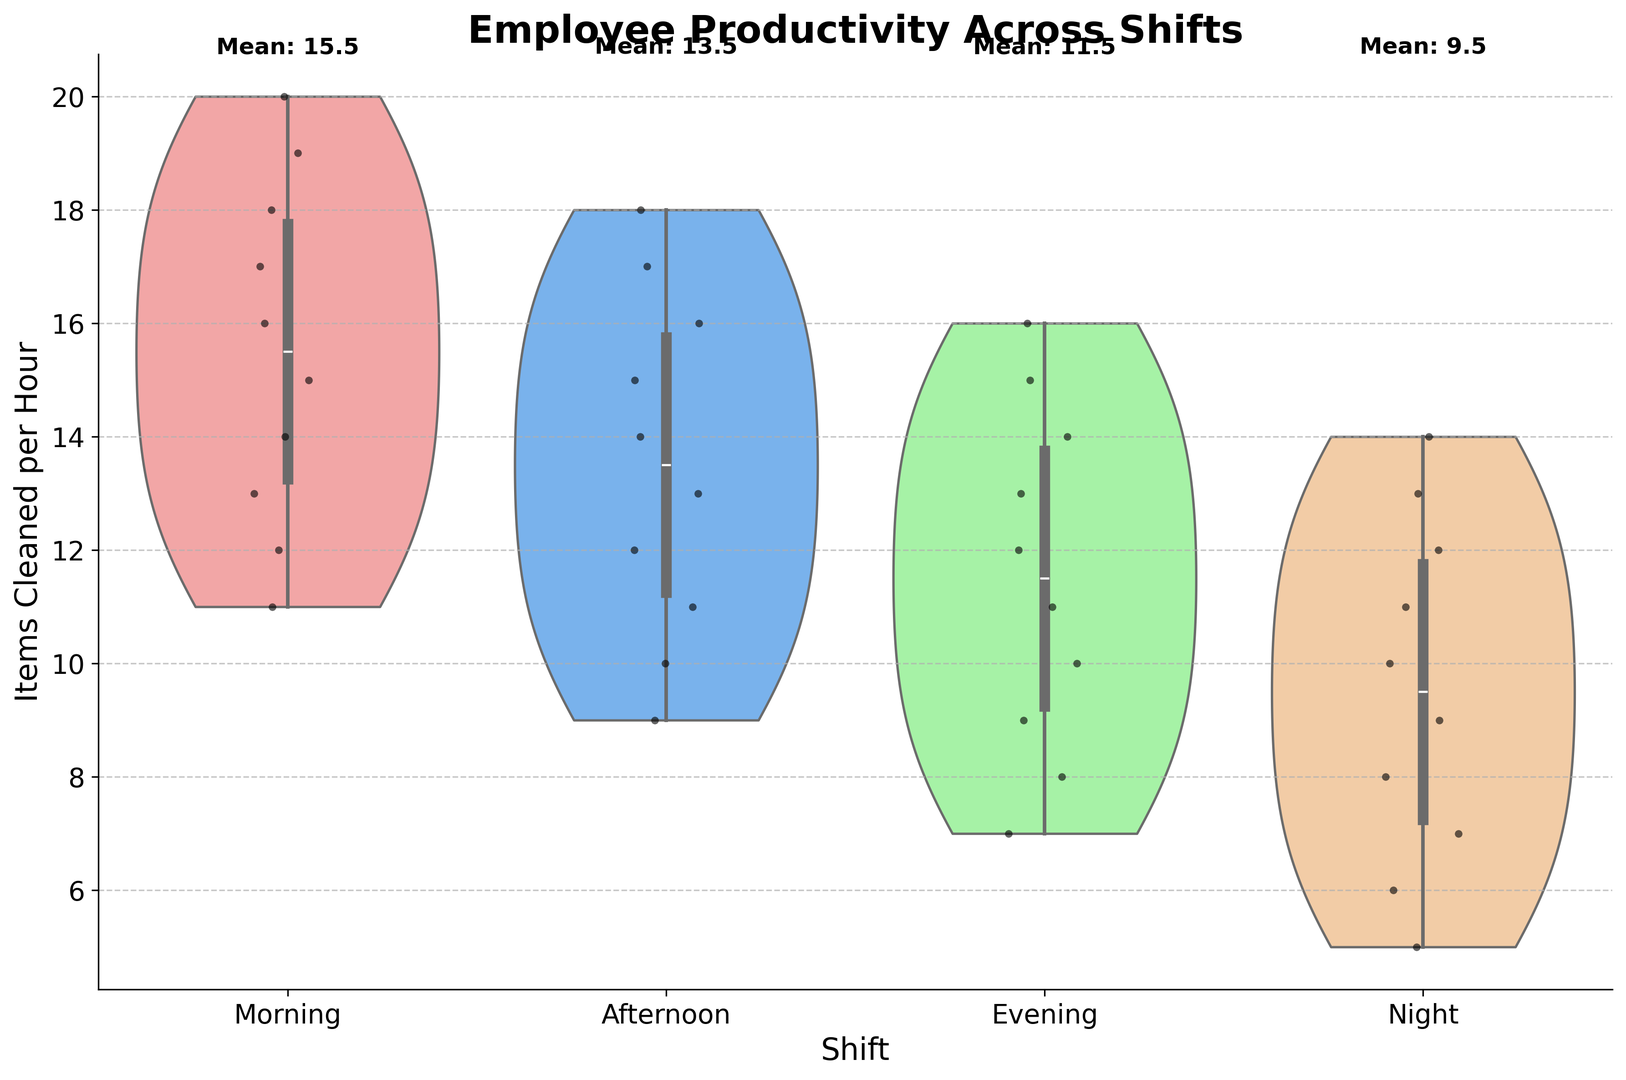What is the most productive shift in terms of the number of items cleaned per hour? The mean annotations in the figure show the average number of items cleaned per hour per shift. The morning shift has the highest mean value.
Answer: Morning Which shift has the widest range of productivity in terms of items cleaned per hour? By observing the spread of the violin plots, the Night shift has the widest range as it spans from 5 to 14 items cleaned per hour.
Answer: Night How does the mean productivity of the Afternoon shift compare to the Morning shift? The figure shows the mean of the Afternoon shift and the Morning shift annotated at the top. The Morning shift's mean is higher than the Afternoon shift's mean.
Answer: The Morning shift has a higher mean What is the median number of items cleaned per hour for the Evening shift? The box inside the violin plot indicates the interquartile range. The median is the line inside the box for the Evening shift.
Answer: 11.5 Which shift has the smallest variability in productivity? The width of the violin plot at each shift reflects the variability. The Afternoon shift has the narrowest plot, indicating the smallest variability.
Answer: Afternoon Compare the maximum productivity values between Morning and Night shifts. The tips of the violin plots show the range of items cleaned per hour. The Morning shift's maximum is 20, while the Night shift's maximum is 14.
Answer: Morning shift has a higher maximum What is the interquartile range (IQR) of the Afternoon shift? The IQR is the range between the 25th and 75th percentiles depicted by the box inside the violin plot. For the Afternoon shift, it spans from 11 to 15 items cleaned per hour.
Answer: 4 How does the productivity distribution of the Evening shift differ visually from the Night shift? The Evening shift has a relatively uniform distribution with no sharp peaks, whereas the Night shift shows a higher concentration in the middle range (around 10 to 11 items).
Answer: Evening is more uniform; Night is more concentrated in the middle What is the approximate mean of the Night shift from the plot annotations? The plot annotations at the top of each shift graph provide the mean value. For the Night shift, it is clearly shown as 10.5.
Answer: 10.5 Is there any overlap in the productivity distributions for the Afternoon and Evening shifts? If yes, specify the range. Observing the spread of both violin plots, there is an overlap in the ranges from 9 to 17 items cleaned per hour.
Answer: Yes, 9 to 17 